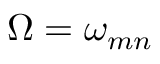<formula> <loc_0><loc_0><loc_500><loc_500>\Omega = \omega _ { m n }</formula> 